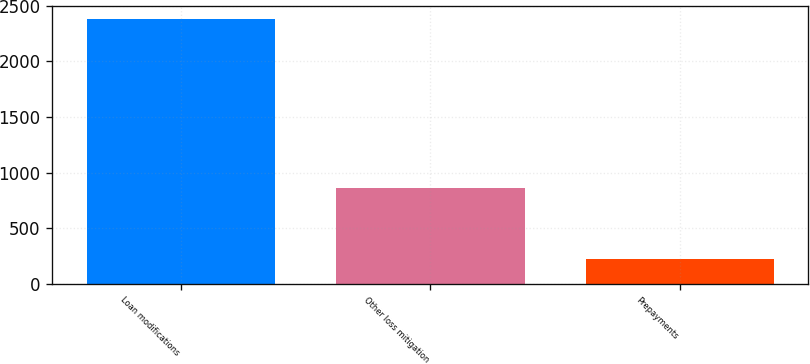<chart> <loc_0><loc_0><loc_500><loc_500><bar_chart><fcel>Loan modifications<fcel>Other loss mitigation<fcel>Prepayments<nl><fcel>2384<fcel>865<fcel>219<nl></chart> 